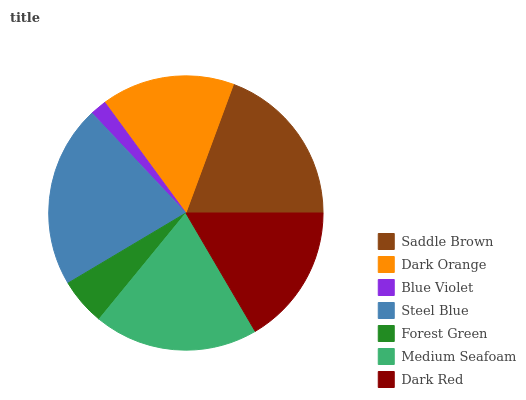Is Blue Violet the minimum?
Answer yes or no. Yes. Is Steel Blue the maximum?
Answer yes or no. Yes. Is Dark Orange the minimum?
Answer yes or no. No. Is Dark Orange the maximum?
Answer yes or no. No. Is Saddle Brown greater than Dark Orange?
Answer yes or no. Yes. Is Dark Orange less than Saddle Brown?
Answer yes or no. Yes. Is Dark Orange greater than Saddle Brown?
Answer yes or no. No. Is Saddle Brown less than Dark Orange?
Answer yes or no. No. Is Dark Red the high median?
Answer yes or no. Yes. Is Dark Red the low median?
Answer yes or no. Yes. Is Medium Seafoam the high median?
Answer yes or no. No. Is Dark Orange the low median?
Answer yes or no. No. 